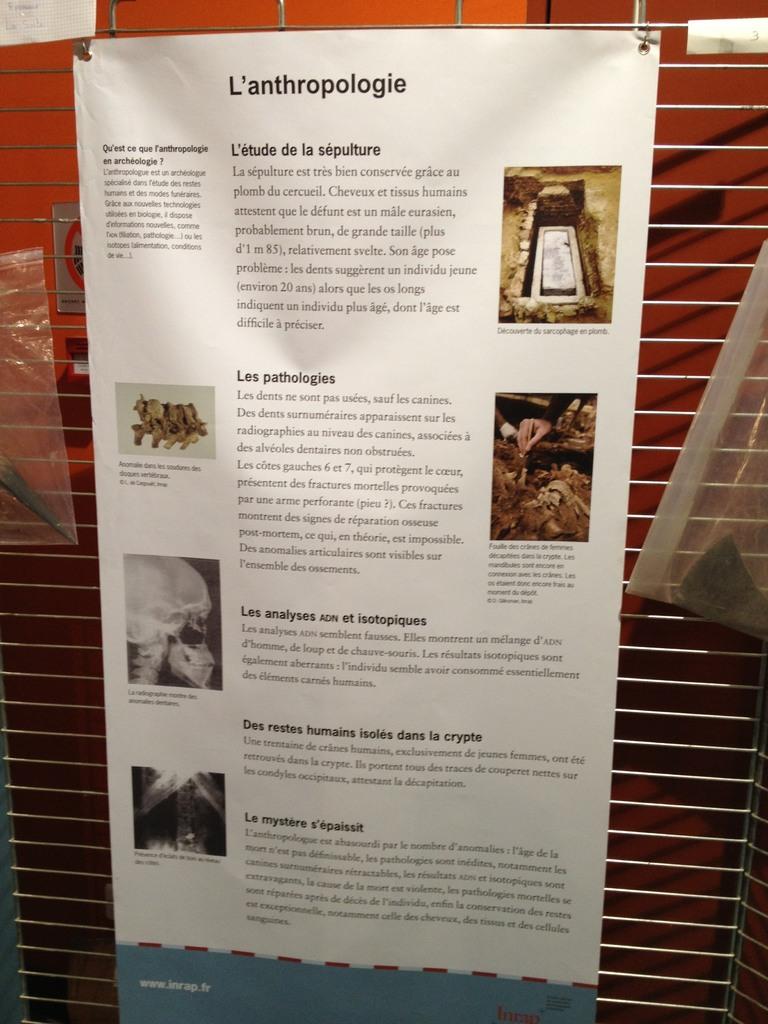How many paragraphs are there?
Your response must be concise. 5. What is the first lettter of the title?
Keep it short and to the point. L. 